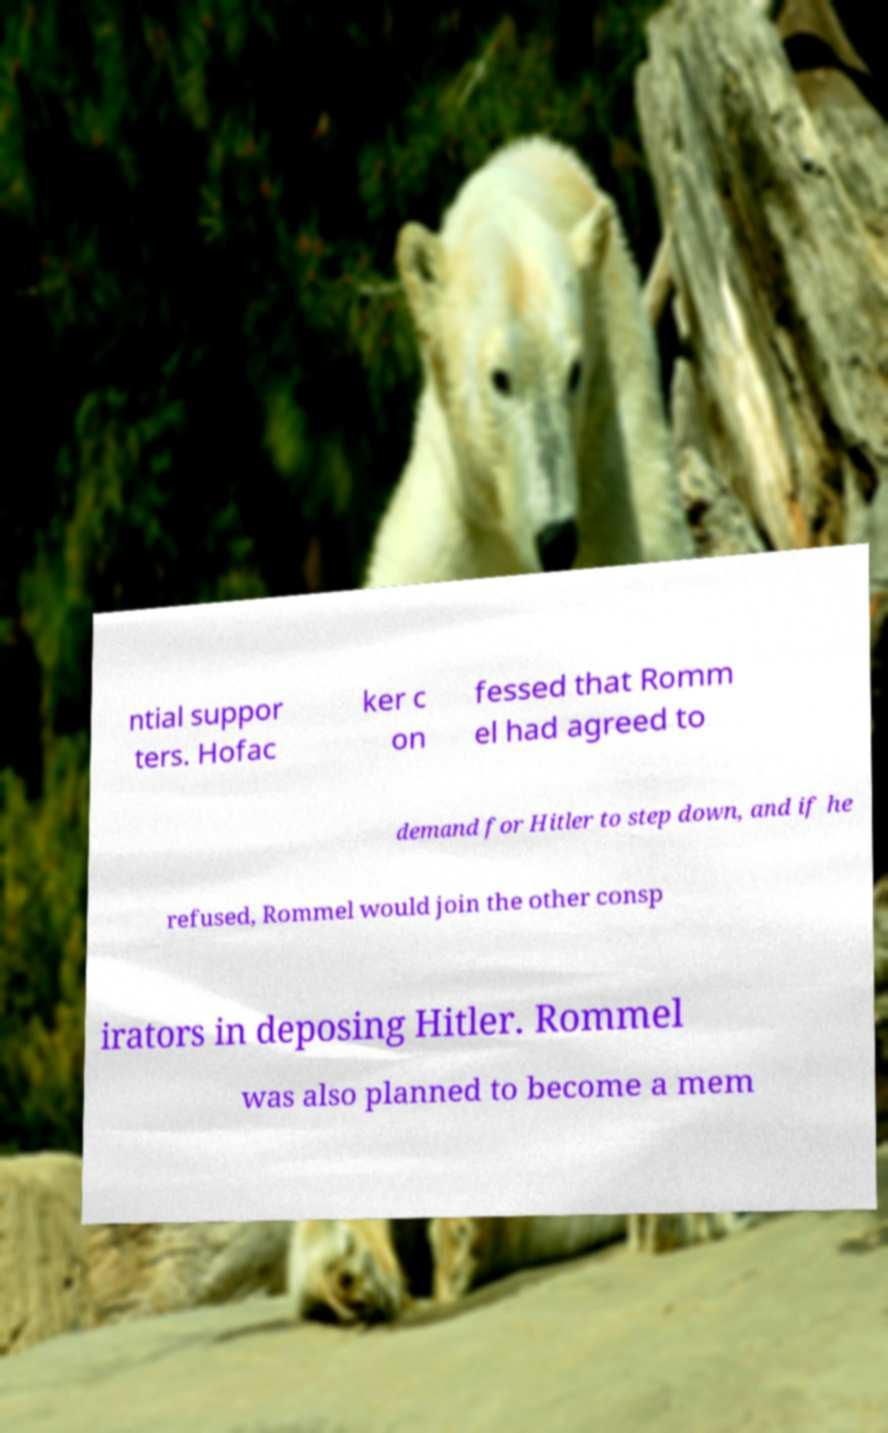What messages or text are displayed in this image? I need them in a readable, typed format. ntial suppor ters. Hofac ker c on fessed that Romm el had agreed to demand for Hitler to step down, and if he refused, Rommel would join the other consp irators in deposing Hitler. Rommel was also planned to become a mem 